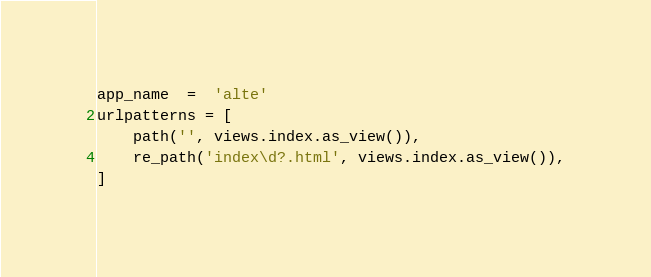<code> <loc_0><loc_0><loc_500><loc_500><_Python_>app_name  =  'alte'
urlpatterns = [
    path('', views.index.as_view()),
    re_path('index\d?.html', views.index.as_view()),
]
</code> 